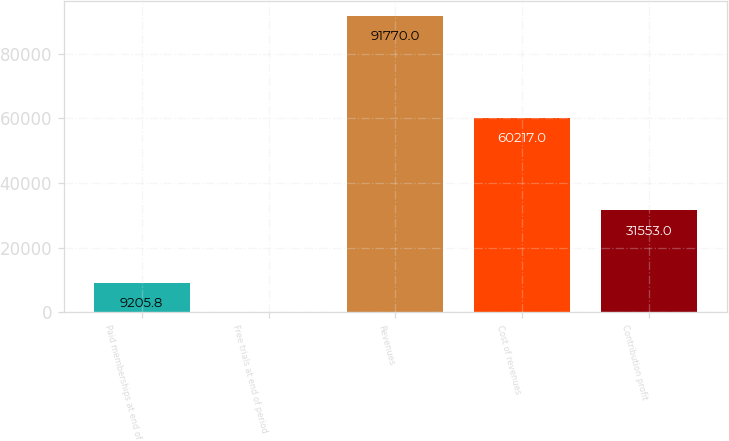<chart> <loc_0><loc_0><loc_500><loc_500><bar_chart><fcel>Paid memberships at end of<fcel>Free trials at end of period<fcel>Revenues<fcel>Cost of revenues<fcel>Contribution profit<nl><fcel>9205.8<fcel>32<fcel>91770<fcel>60217<fcel>31553<nl></chart> 